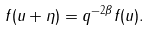Convert formula to latex. <formula><loc_0><loc_0><loc_500><loc_500>f ( u + \eta ) = q ^ { - 2 \beta } f ( u ) .</formula> 